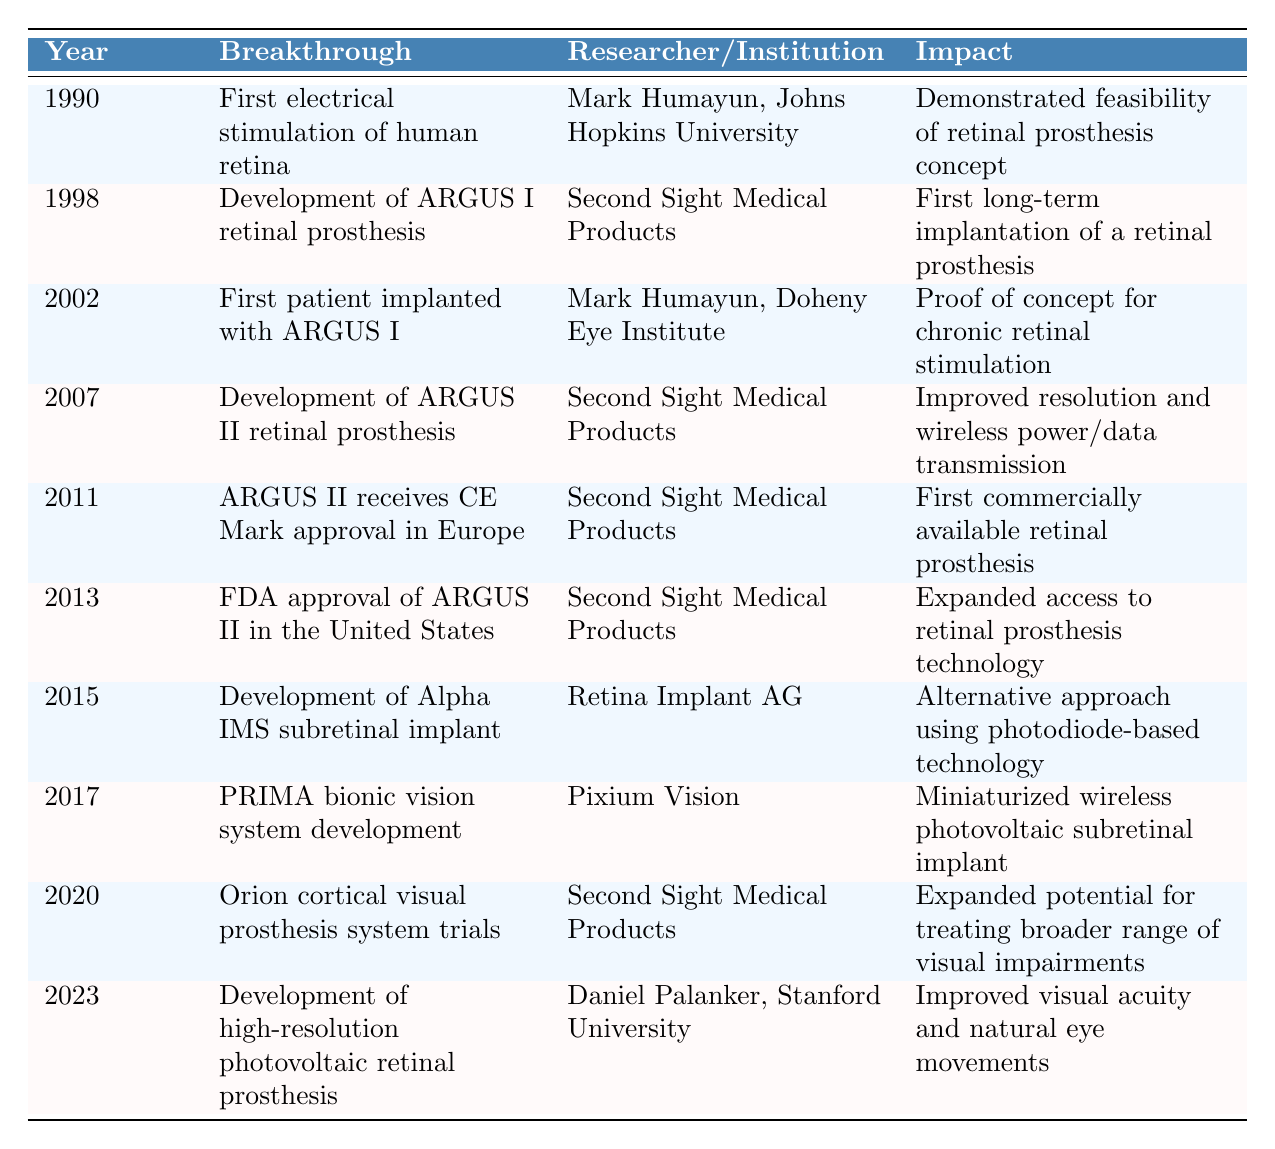What year did the first electrical stimulation of the human retina occur? The table lists the year 1990 for the first electrical stimulation of the human retina.
Answer: 1990 Who developed the ARGUS I retinal prosthesis? According to the table, the ARGUS I retinal prosthesis was developed by Second Sight Medical Products.
Answer: Second Sight Medical Products What was the impact of the 2013 FDA approval of ARGUS II? The table states that the FDA approval of ARGUS II in 2013 expanded access to retinal prosthesis technology.
Answer: Expanded access to retinal prosthesis technology In what year was the first patient implanted with ARGUS I? The table indicates that the first patient was implanted with ARGUS I in 2002.
Answer: 2002 Which breakthrough occurred in 2017, and which institution was involved? The breakthrough in 2017 was the development of the PRIMA bionic vision system by Pixium Vision, as listed in the table.
Answer: PRIMA bionic vision system by Pixium Vision How many breakthroughs were developed by Second Sight Medical Products? I can count the occurrences. The breakthroughs by Second Sight Medical Products are in 1998, 2007, 2011, 2013, and 2020, totaling 5 developments.
Answer: 5 What is the impact of the 2023 development of the high-resolution photovoltaic retinal prosthesis? The table mentions that the impact is improved visual acuity and natural eye movements.
Answer: Improved visual acuity and natural eye movements Did Retina Implant AG develop the ARGUS I retinal prosthesis? The table states that Retina Implant AG developed the Alpha IMS subretinal implant, not the ARGUS I, which was developed by Second Sight Medical Products. This means the statement is false.
Answer: No List the years when significant retinal prosthesis developments occurred between 2011 and 2023. The table indicates that developments occurred in 2011, 2013, 2015, 2017, 2020, and 2023. To compile the years, one can look for rows within the 2011 to 2023 range.
Answer: 2011, 2013, 2015, 2017, 2020, 2023 Which retinal prosthesis was the first commercially available in Europe? The table shows that the ARGUS II received CE Mark approval in Europe in 2011, making it the first commercially available retinal prosthesis.
Answer: ARGUS II 